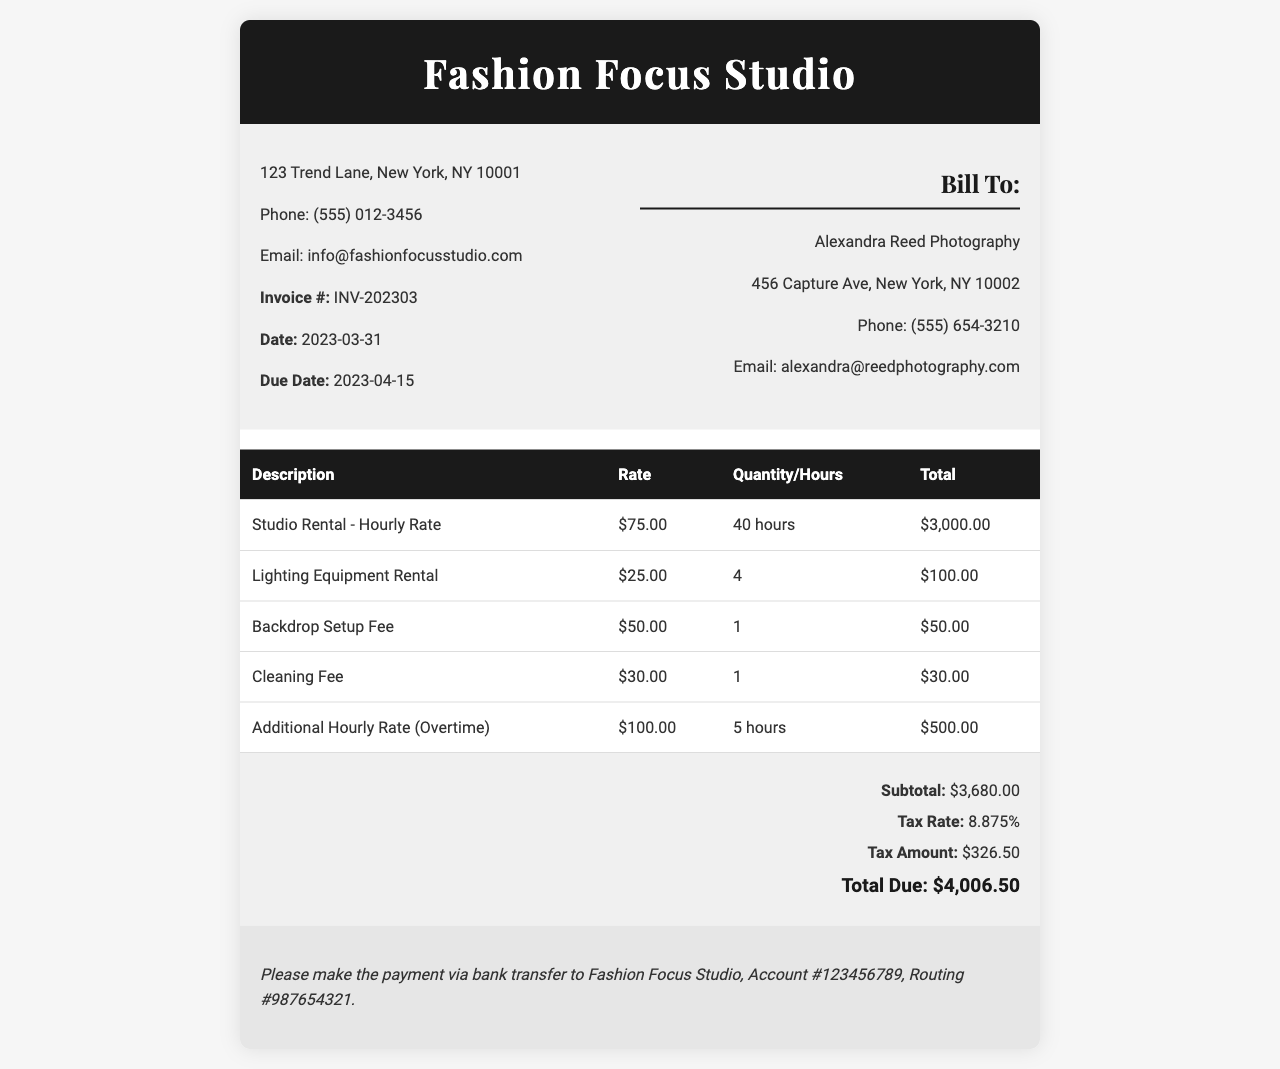What is the invoice number? The invoice number is listed in the document as a unique identifier for this transaction, which is INV-202303.
Answer: INV-202303 What is the total due amount? The total due is the final amount to be paid, calculated after tax, which is $4,006.50.
Answer: $4,006.50 How many hours of studio rental were charged? The invoice specifies the quantity of studio rental hours that were billed, which is 40 hours.
Answer: 40 hours What is the tax rate applied to the invoice? The tax rate is stated in the document, which is 8.875%.
Answer: 8.875% Who is the bill recipient? The bill recipient's name is provided in the billing details, which is Alexandra Reed Photography.
Answer: Alexandra Reed Photography What was the charge for the cleaning fee? The cleaning fee is listed as a separate service fee on the invoice, which is $30.00.
Answer: $30.00 What is the subtotal before tax? The subtotal is the total before any taxes are added, stated in the invoice as $3,680.00.
Answer: $3,680.00 How many additional hours were charged at the overtime rate? The document specifies the quantity of additional hours charged as overtime, which is 5 hours.
Answer: 5 hours What is the payment due date? The due date for the payment is clearly stated in the document, which is 2023-04-15.
Answer: 2023-04-15 